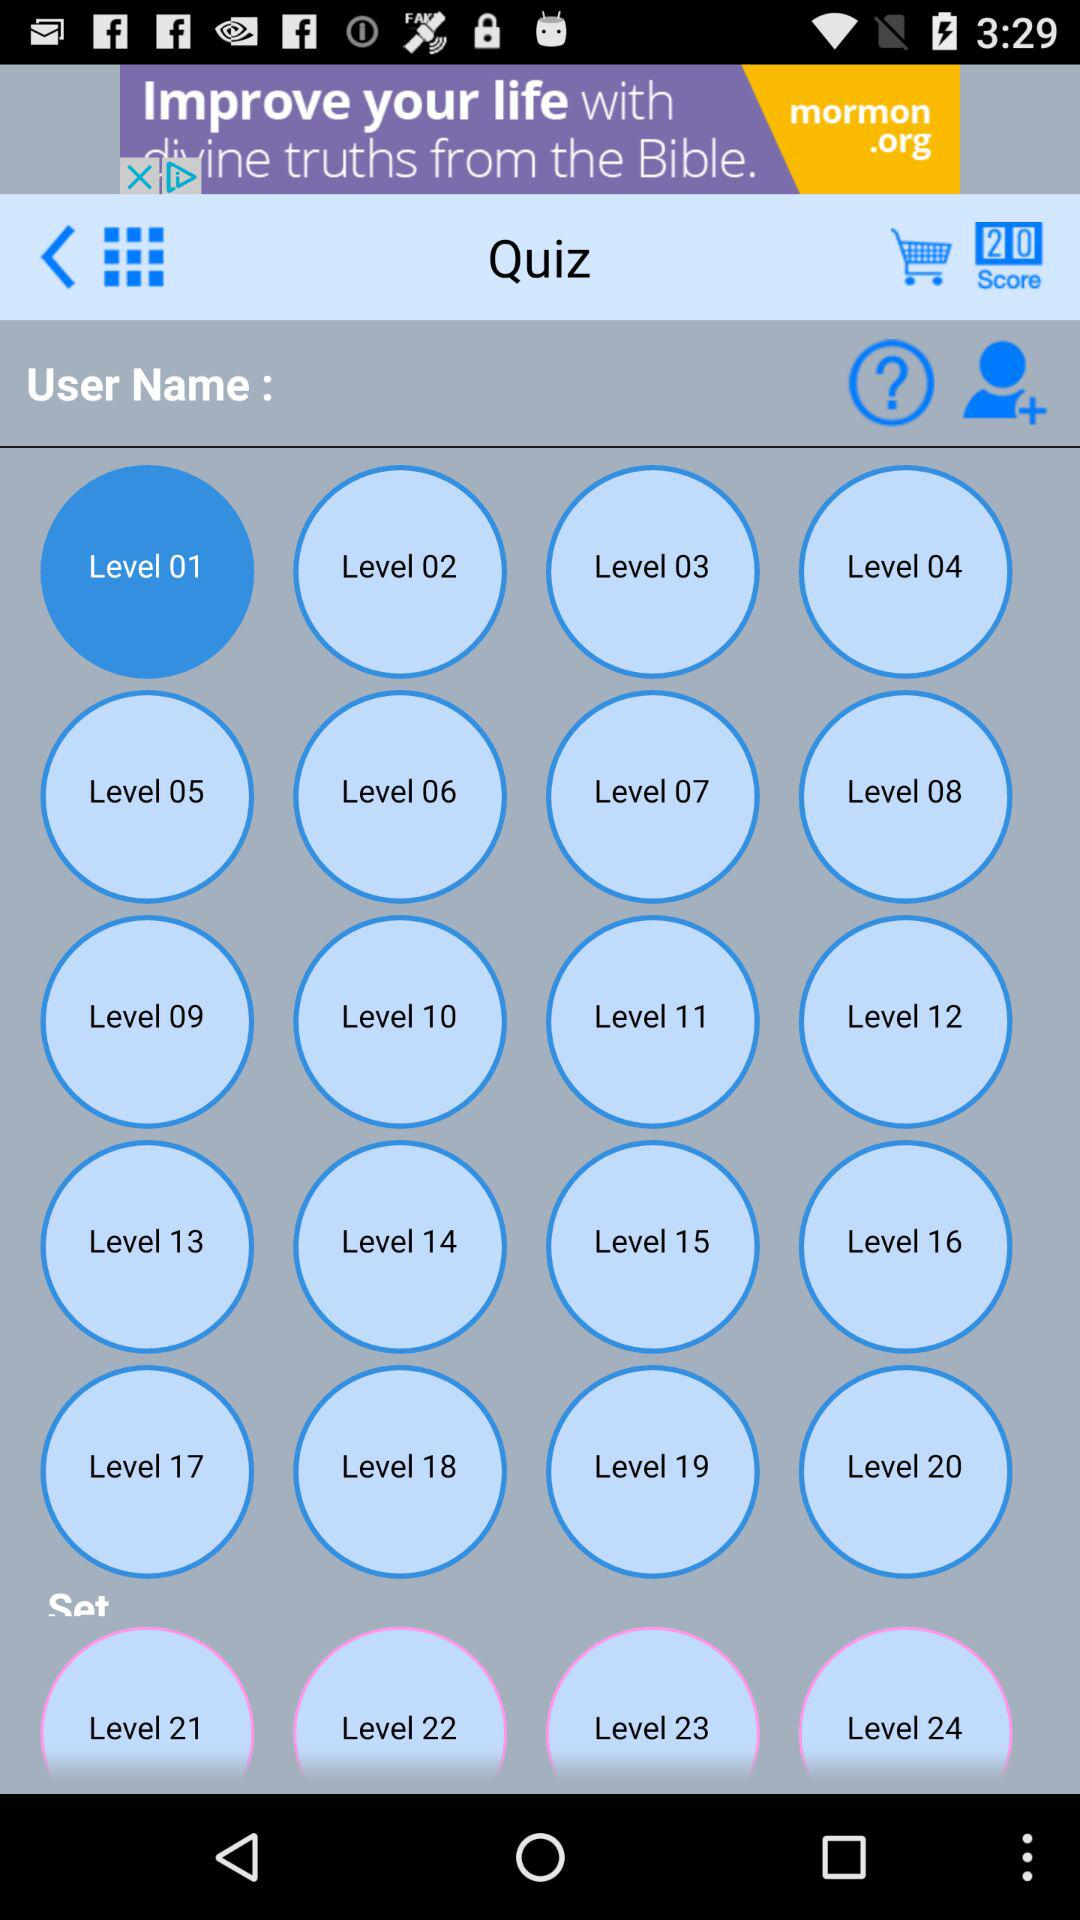Currently, are we on which level? Currently, you are on level 1. 